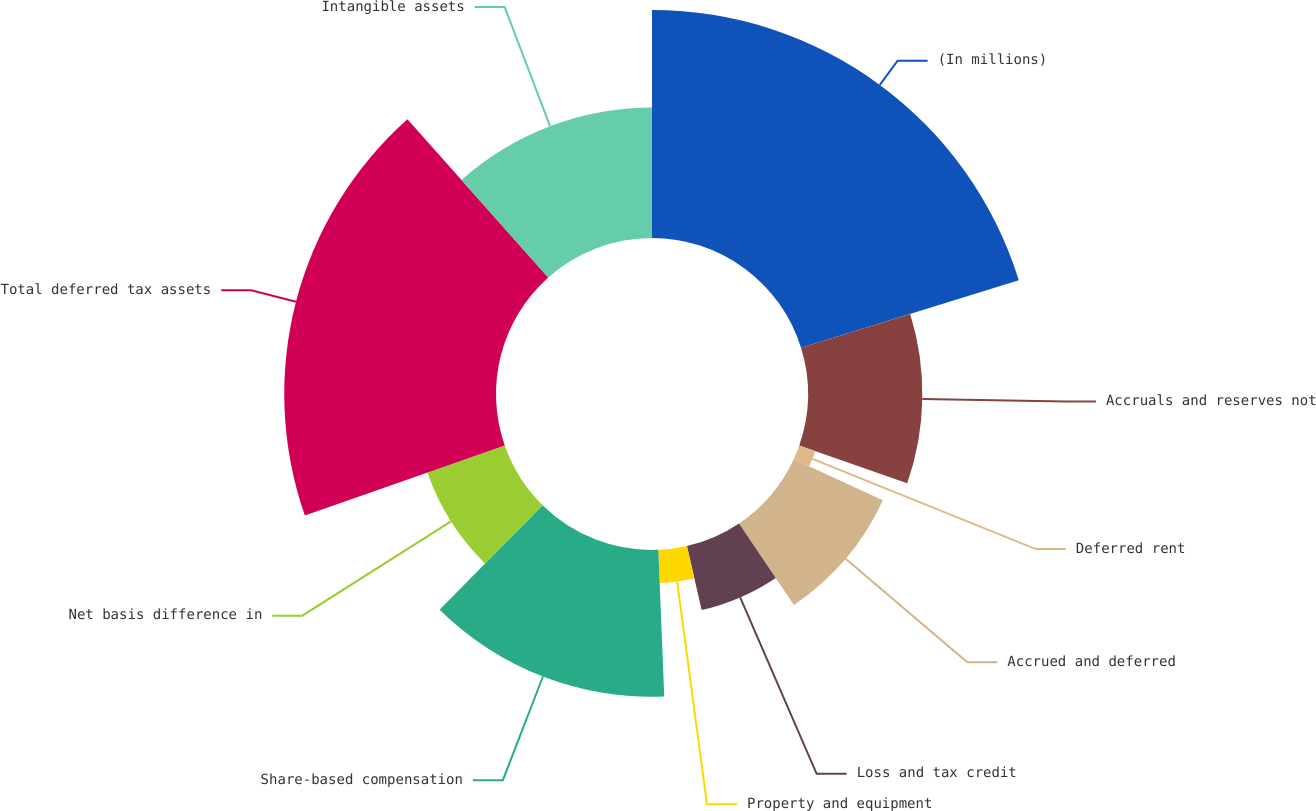<chart> <loc_0><loc_0><loc_500><loc_500><pie_chart><fcel>(In millions)<fcel>Accruals and reserves not<fcel>Deferred rent<fcel>Accrued and deferred<fcel>Loss and tax credit<fcel>Property and equipment<fcel>Share-based compensation<fcel>Net basis difference in<fcel>Total deferred tax assets<fcel>Intangible assets<nl><fcel>20.22%<fcel>10.14%<fcel>1.51%<fcel>8.71%<fcel>5.83%<fcel>2.95%<fcel>13.02%<fcel>7.27%<fcel>18.78%<fcel>11.58%<nl></chart> 